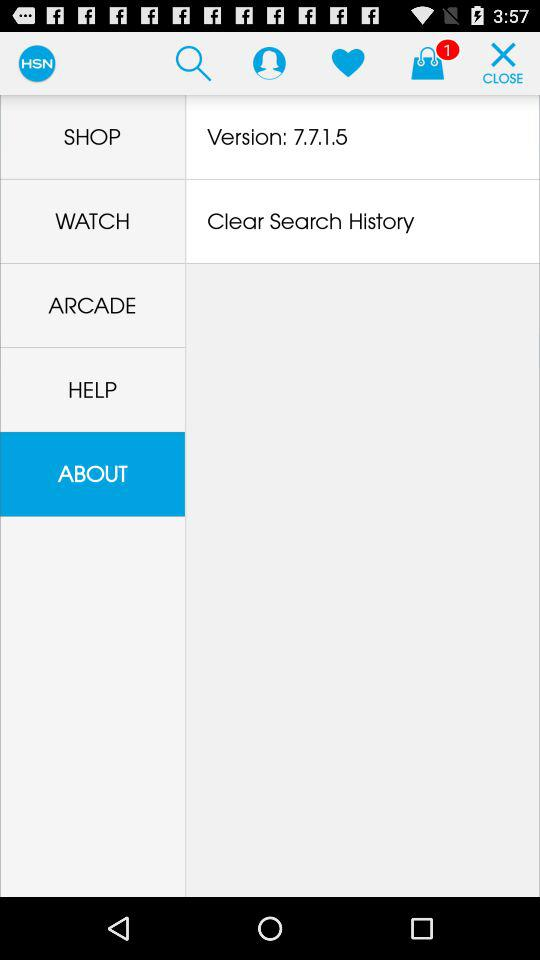What is the version number? The version number is 7.7.1.5. 